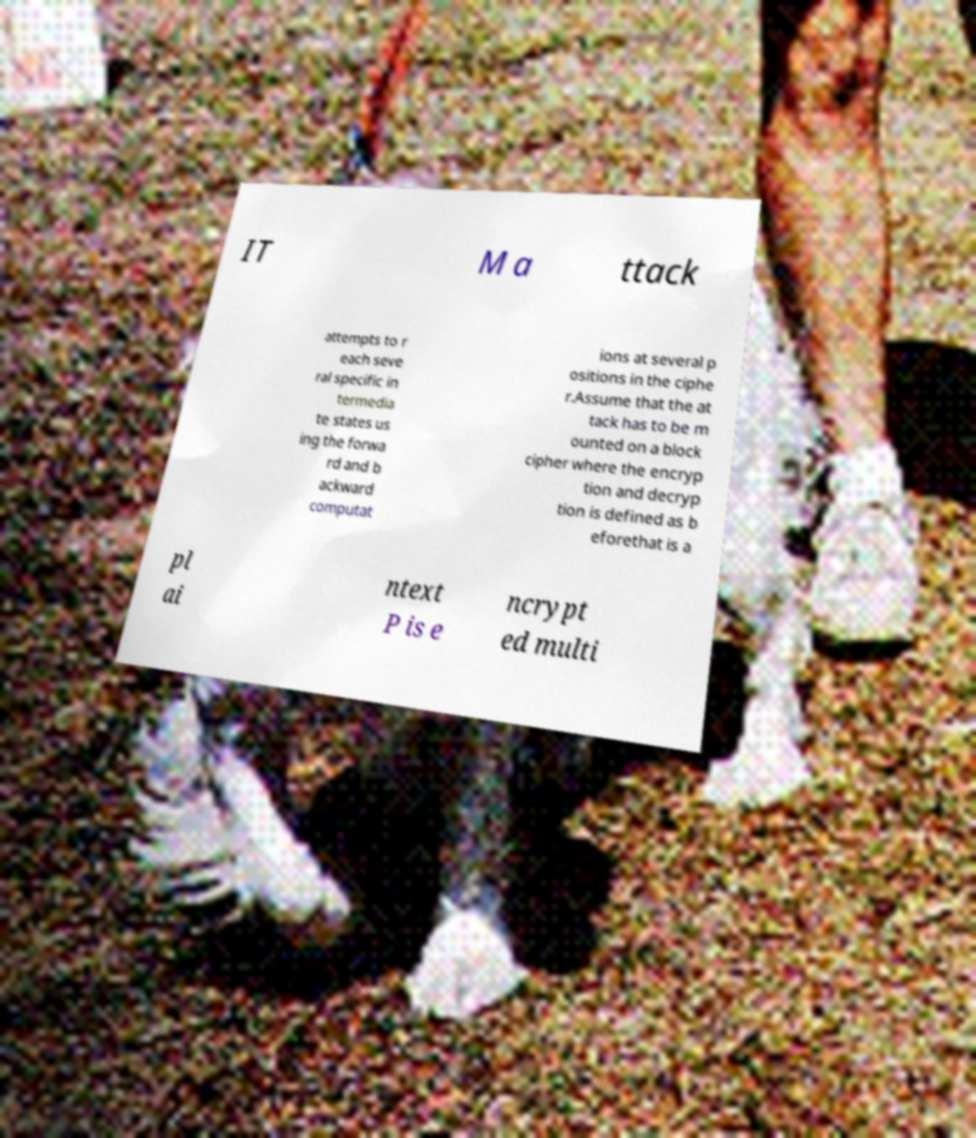Please read and relay the text visible in this image. What does it say? IT M a ttack attempts to r each seve ral specific in termedia te states us ing the forwa rd and b ackward computat ions at several p ositions in the ciphe r.Assume that the at tack has to be m ounted on a block cipher where the encryp tion and decryp tion is defined as b eforethat is a pl ai ntext P is e ncrypt ed multi 